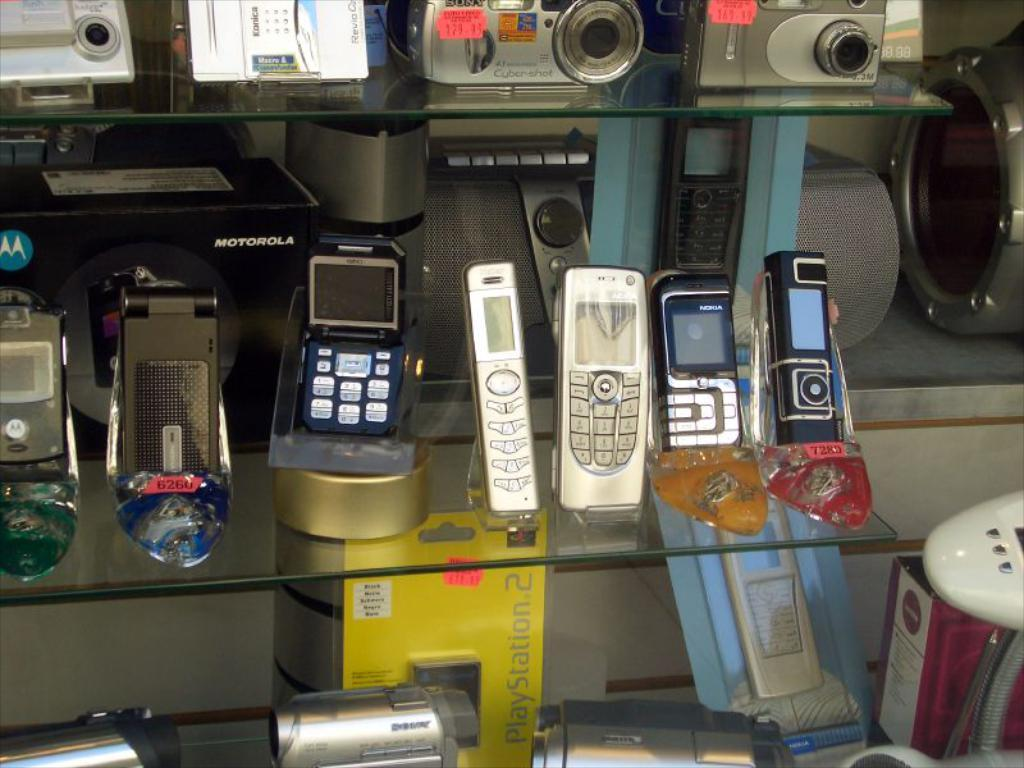Provide a one-sentence caption for the provided image. a yellow box that has the words play station 2 on it. 